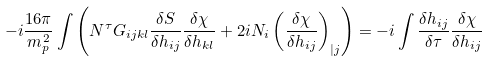Convert formula to latex. <formula><loc_0><loc_0><loc_500><loc_500>- i \frac { 1 6 \pi } { m _ { p } ^ { \, 2 } } \int \left ( N ^ { \tau } G _ { i j k l } \frac { \delta S } { \delta h _ { i j } } \frac { \delta \chi } { \delta h _ { k l } } + 2 i N _ { i } \left ( \frac { \delta \chi } { \delta h _ { i j } } \right ) _ { | j } \right ) = - i \int \frac { \delta h _ { i j } } { \delta \tau } \frac { \delta \chi } { \delta h _ { i j } }</formula> 